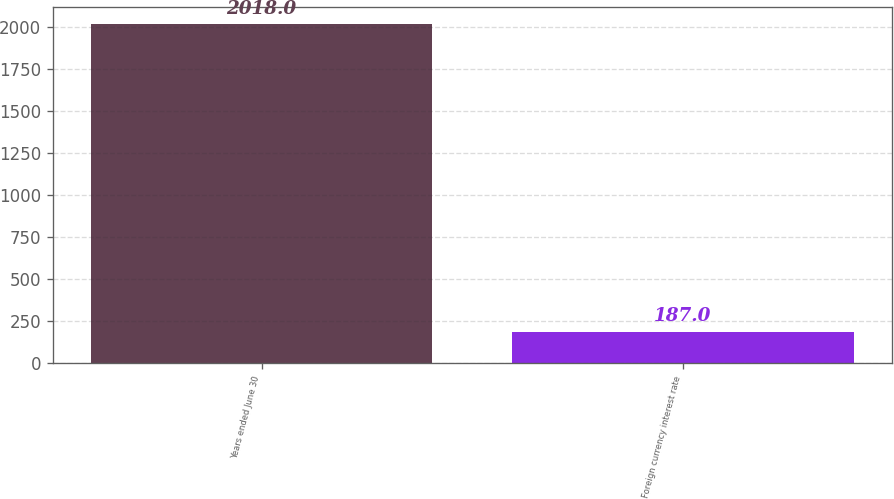Convert chart. <chart><loc_0><loc_0><loc_500><loc_500><bar_chart><fcel>Years ended June 30<fcel>Foreign currency interest rate<nl><fcel>2018<fcel>187<nl></chart> 